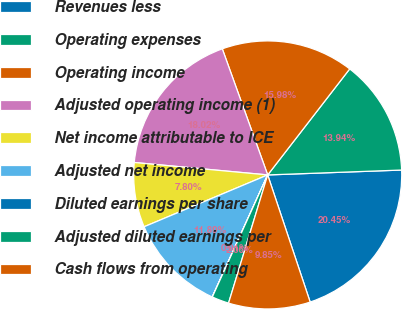<chart> <loc_0><loc_0><loc_500><loc_500><pie_chart><fcel>Revenues less<fcel>Operating expenses<fcel>Operating income<fcel>Adjusted operating income (1)<fcel>Net income attributable to ICE<fcel>Adjusted net income<fcel>Diluted earnings per share<fcel>Adjusted diluted earnings per<fcel>Cash flows from operating<nl><fcel>20.45%<fcel>13.94%<fcel>15.98%<fcel>18.02%<fcel>7.8%<fcel>11.89%<fcel>0.01%<fcel>2.06%<fcel>9.85%<nl></chart> 